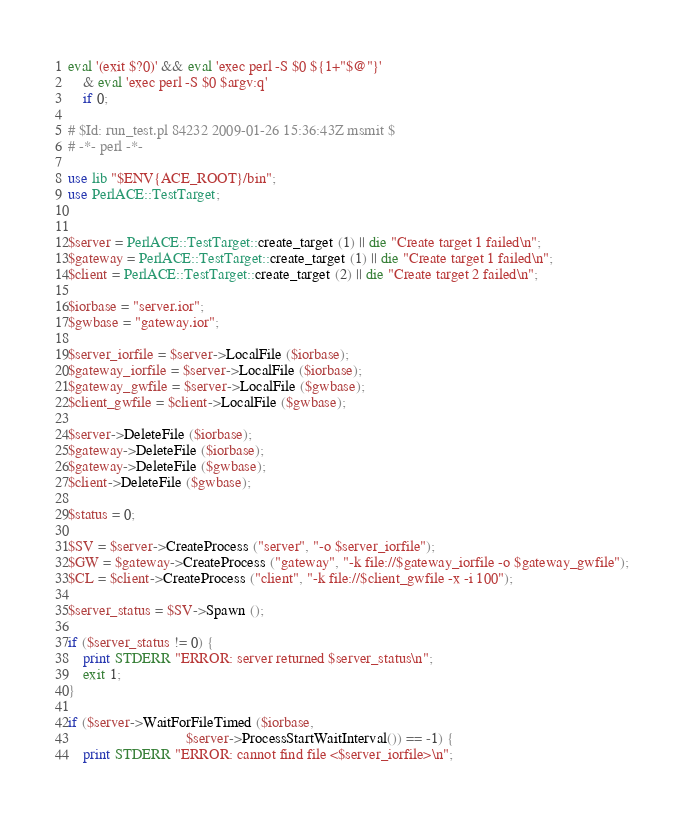<code> <loc_0><loc_0><loc_500><loc_500><_Perl_>eval '(exit $?0)' && eval 'exec perl -S $0 ${1+"$@"}'
    & eval 'exec perl -S $0 $argv:q'
    if 0;

# $Id: run_test.pl 84232 2009-01-26 15:36:43Z msmit $
# -*- perl -*-

use lib "$ENV{ACE_ROOT}/bin";
use PerlACE::TestTarget;


$server = PerlACE::TestTarget::create_target (1) || die "Create target 1 failed\n";
$gateway = PerlACE::TestTarget::create_target (1) || die "Create target 1 failed\n";
$client = PerlACE::TestTarget::create_target (2) || die "Create target 2 failed\n";

$iorbase = "server.ior";
$gwbase = "gateway.ior";

$server_iorfile = $server->LocalFile ($iorbase);
$gateway_iorfile = $server->LocalFile ($iorbase);
$gateway_gwfile = $server->LocalFile ($gwbase);
$client_gwfile = $client->LocalFile ($gwbase);

$server->DeleteFile ($iorbase);
$gateway->DeleteFile ($iorbase);
$gateway->DeleteFile ($gwbase);
$client->DeleteFile ($gwbase);

$status = 0;

$SV = $server->CreateProcess ("server", "-o $server_iorfile");
$GW = $gateway->CreateProcess ("gateway", "-k file://$gateway_iorfile -o $gateway_gwfile");
$CL = $client->CreateProcess ("client", "-k file://$client_gwfile -x -i 100");

$server_status = $SV->Spawn ();

if ($server_status != 0) {
    print STDERR "ERROR: server returned $server_status\n";
    exit 1;
}

if ($server->WaitForFileTimed ($iorbase,
                               $server->ProcessStartWaitInterval()) == -1) {
    print STDERR "ERROR: cannot find file <$server_iorfile>\n";</code> 